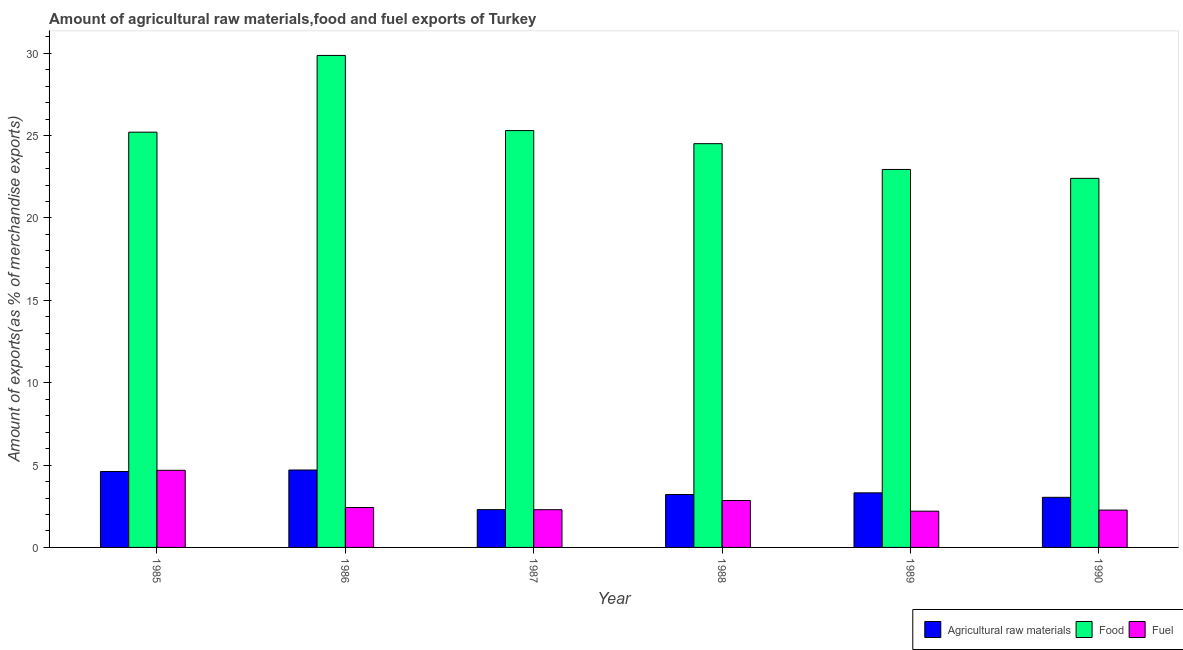How many different coloured bars are there?
Offer a terse response. 3. How many groups of bars are there?
Offer a very short reply. 6. How many bars are there on the 1st tick from the right?
Provide a succinct answer. 3. What is the label of the 3rd group of bars from the left?
Your answer should be very brief. 1987. What is the percentage of raw materials exports in 1986?
Make the answer very short. 4.7. Across all years, what is the maximum percentage of food exports?
Offer a very short reply. 29.87. Across all years, what is the minimum percentage of fuel exports?
Make the answer very short. 2.2. What is the total percentage of raw materials exports in the graph?
Your response must be concise. 21.17. What is the difference between the percentage of fuel exports in 1985 and that in 1989?
Offer a terse response. 2.48. What is the difference between the percentage of raw materials exports in 1985 and the percentage of food exports in 1988?
Make the answer very short. 1.4. What is the average percentage of raw materials exports per year?
Your answer should be compact. 3.53. In how many years, is the percentage of raw materials exports greater than 13 %?
Make the answer very short. 0. What is the ratio of the percentage of fuel exports in 1986 to that in 1990?
Provide a short and direct response. 1.07. Is the percentage of raw materials exports in 1985 less than that in 1988?
Your response must be concise. No. Is the difference between the percentage of food exports in 1985 and 1986 greater than the difference between the percentage of raw materials exports in 1985 and 1986?
Offer a very short reply. No. What is the difference between the highest and the second highest percentage of raw materials exports?
Ensure brevity in your answer.  0.09. What is the difference between the highest and the lowest percentage of fuel exports?
Keep it short and to the point. 2.48. What does the 2nd bar from the left in 1989 represents?
Your response must be concise. Food. What does the 3rd bar from the right in 1987 represents?
Provide a succinct answer. Agricultural raw materials. Are all the bars in the graph horizontal?
Ensure brevity in your answer.  No. How many years are there in the graph?
Offer a very short reply. 6. Are the values on the major ticks of Y-axis written in scientific E-notation?
Your answer should be very brief. No. Does the graph contain any zero values?
Your response must be concise. No. Where does the legend appear in the graph?
Offer a terse response. Bottom right. How many legend labels are there?
Provide a short and direct response. 3. How are the legend labels stacked?
Your answer should be compact. Horizontal. What is the title of the graph?
Give a very brief answer. Amount of agricultural raw materials,food and fuel exports of Turkey. Does "Solid fuel" appear as one of the legend labels in the graph?
Your response must be concise. No. What is the label or title of the X-axis?
Your answer should be very brief. Year. What is the label or title of the Y-axis?
Make the answer very short. Amount of exports(as % of merchandise exports). What is the Amount of exports(as % of merchandise exports) of Agricultural raw materials in 1985?
Your response must be concise. 4.61. What is the Amount of exports(as % of merchandise exports) in Food in 1985?
Your response must be concise. 25.21. What is the Amount of exports(as % of merchandise exports) of Fuel in 1985?
Keep it short and to the point. 4.68. What is the Amount of exports(as % of merchandise exports) in Agricultural raw materials in 1986?
Your answer should be very brief. 4.7. What is the Amount of exports(as % of merchandise exports) of Food in 1986?
Provide a succinct answer. 29.87. What is the Amount of exports(as % of merchandise exports) in Fuel in 1986?
Make the answer very short. 2.42. What is the Amount of exports(as % of merchandise exports) of Agricultural raw materials in 1987?
Give a very brief answer. 2.29. What is the Amount of exports(as % of merchandise exports) in Food in 1987?
Give a very brief answer. 25.3. What is the Amount of exports(as % of merchandise exports) of Fuel in 1987?
Give a very brief answer. 2.29. What is the Amount of exports(as % of merchandise exports) of Agricultural raw materials in 1988?
Provide a succinct answer. 3.21. What is the Amount of exports(as % of merchandise exports) in Food in 1988?
Give a very brief answer. 24.51. What is the Amount of exports(as % of merchandise exports) of Fuel in 1988?
Ensure brevity in your answer.  2.85. What is the Amount of exports(as % of merchandise exports) in Agricultural raw materials in 1989?
Provide a succinct answer. 3.31. What is the Amount of exports(as % of merchandise exports) in Food in 1989?
Your answer should be very brief. 22.94. What is the Amount of exports(as % of merchandise exports) in Fuel in 1989?
Give a very brief answer. 2.2. What is the Amount of exports(as % of merchandise exports) in Agricultural raw materials in 1990?
Your answer should be very brief. 3.04. What is the Amount of exports(as % of merchandise exports) in Food in 1990?
Offer a very short reply. 22.41. What is the Amount of exports(as % of merchandise exports) in Fuel in 1990?
Provide a short and direct response. 2.27. Across all years, what is the maximum Amount of exports(as % of merchandise exports) of Agricultural raw materials?
Your answer should be very brief. 4.7. Across all years, what is the maximum Amount of exports(as % of merchandise exports) of Food?
Provide a short and direct response. 29.87. Across all years, what is the maximum Amount of exports(as % of merchandise exports) of Fuel?
Keep it short and to the point. 4.68. Across all years, what is the minimum Amount of exports(as % of merchandise exports) in Agricultural raw materials?
Offer a very short reply. 2.29. Across all years, what is the minimum Amount of exports(as % of merchandise exports) of Food?
Your answer should be very brief. 22.41. Across all years, what is the minimum Amount of exports(as % of merchandise exports) in Fuel?
Give a very brief answer. 2.2. What is the total Amount of exports(as % of merchandise exports) in Agricultural raw materials in the graph?
Ensure brevity in your answer.  21.17. What is the total Amount of exports(as % of merchandise exports) of Food in the graph?
Provide a succinct answer. 150.24. What is the total Amount of exports(as % of merchandise exports) of Fuel in the graph?
Ensure brevity in your answer.  16.71. What is the difference between the Amount of exports(as % of merchandise exports) in Agricultural raw materials in 1985 and that in 1986?
Provide a short and direct response. -0.09. What is the difference between the Amount of exports(as % of merchandise exports) of Food in 1985 and that in 1986?
Offer a terse response. -4.66. What is the difference between the Amount of exports(as % of merchandise exports) in Fuel in 1985 and that in 1986?
Your answer should be very brief. 2.26. What is the difference between the Amount of exports(as % of merchandise exports) of Agricultural raw materials in 1985 and that in 1987?
Provide a short and direct response. 2.32. What is the difference between the Amount of exports(as % of merchandise exports) in Food in 1985 and that in 1987?
Offer a very short reply. -0.1. What is the difference between the Amount of exports(as % of merchandise exports) of Fuel in 1985 and that in 1987?
Your response must be concise. 2.39. What is the difference between the Amount of exports(as % of merchandise exports) of Agricultural raw materials in 1985 and that in 1988?
Ensure brevity in your answer.  1.4. What is the difference between the Amount of exports(as % of merchandise exports) of Food in 1985 and that in 1988?
Ensure brevity in your answer.  0.7. What is the difference between the Amount of exports(as % of merchandise exports) in Fuel in 1985 and that in 1988?
Offer a terse response. 1.83. What is the difference between the Amount of exports(as % of merchandise exports) in Agricultural raw materials in 1985 and that in 1989?
Ensure brevity in your answer.  1.3. What is the difference between the Amount of exports(as % of merchandise exports) in Food in 1985 and that in 1989?
Offer a very short reply. 2.26. What is the difference between the Amount of exports(as % of merchandise exports) of Fuel in 1985 and that in 1989?
Give a very brief answer. 2.48. What is the difference between the Amount of exports(as % of merchandise exports) of Agricultural raw materials in 1985 and that in 1990?
Provide a succinct answer. 1.57. What is the difference between the Amount of exports(as % of merchandise exports) of Food in 1985 and that in 1990?
Your answer should be very brief. 2.8. What is the difference between the Amount of exports(as % of merchandise exports) in Fuel in 1985 and that in 1990?
Your answer should be compact. 2.41. What is the difference between the Amount of exports(as % of merchandise exports) in Agricultural raw materials in 1986 and that in 1987?
Provide a succinct answer. 2.41. What is the difference between the Amount of exports(as % of merchandise exports) of Food in 1986 and that in 1987?
Your answer should be compact. 4.56. What is the difference between the Amount of exports(as % of merchandise exports) of Fuel in 1986 and that in 1987?
Provide a succinct answer. 0.13. What is the difference between the Amount of exports(as % of merchandise exports) in Agricultural raw materials in 1986 and that in 1988?
Offer a terse response. 1.49. What is the difference between the Amount of exports(as % of merchandise exports) in Food in 1986 and that in 1988?
Provide a succinct answer. 5.36. What is the difference between the Amount of exports(as % of merchandise exports) of Fuel in 1986 and that in 1988?
Provide a succinct answer. -0.43. What is the difference between the Amount of exports(as % of merchandise exports) in Agricultural raw materials in 1986 and that in 1989?
Your response must be concise. 1.39. What is the difference between the Amount of exports(as % of merchandise exports) in Food in 1986 and that in 1989?
Offer a very short reply. 6.92. What is the difference between the Amount of exports(as % of merchandise exports) of Fuel in 1986 and that in 1989?
Provide a succinct answer. 0.22. What is the difference between the Amount of exports(as % of merchandise exports) in Agricultural raw materials in 1986 and that in 1990?
Your answer should be compact. 1.66. What is the difference between the Amount of exports(as % of merchandise exports) in Food in 1986 and that in 1990?
Give a very brief answer. 7.46. What is the difference between the Amount of exports(as % of merchandise exports) of Fuel in 1986 and that in 1990?
Provide a succinct answer. 0.16. What is the difference between the Amount of exports(as % of merchandise exports) of Agricultural raw materials in 1987 and that in 1988?
Ensure brevity in your answer.  -0.92. What is the difference between the Amount of exports(as % of merchandise exports) of Food in 1987 and that in 1988?
Keep it short and to the point. 0.79. What is the difference between the Amount of exports(as % of merchandise exports) in Fuel in 1987 and that in 1988?
Give a very brief answer. -0.56. What is the difference between the Amount of exports(as % of merchandise exports) in Agricultural raw materials in 1987 and that in 1989?
Your response must be concise. -1.02. What is the difference between the Amount of exports(as % of merchandise exports) of Food in 1987 and that in 1989?
Provide a short and direct response. 2.36. What is the difference between the Amount of exports(as % of merchandise exports) of Fuel in 1987 and that in 1989?
Keep it short and to the point. 0.09. What is the difference between the Amount of exports(as % of merchandise exports) of Agricultural raw materials in 1987 and that in 1990?
Offer a terse response. -0.75. What is the difference between the Amount of exports(as % of merchandise exports) in Food in 1987 and that in 1990?
Provide a short and direct response. 2.9. What is the difference between the Amount of exports(as % of merchandise exports) in Fuel in 1987 and that in 1990?
Give a very brief answer. 0.02. What is the difference between the Amount of exports(as % of merchandise exports) of Agricultural raw materials in 1988 and that in 1989?
Your answer should be compact. -0.1. What is the difference between the Amount of exports(as % of merchandise exports) of Food in 1988 and that in 1989?
Offer a very short reply. 1.56. What is the difference between the Amount of exports(as % of merchandise exports) of Fuel in 1988 and that in 1989?
Provide a short and direct response. 0.65. What is the difference between the Amount of exports(as % of merchandise exports) of Agricultural raw materials in 1988 and that in 1990?
Keep it short and to the point. 0.17. What is the difference between the Amount of exports(as % of merchandise exports) of Food in 1988 and that in 1990?
Give a very brief answer. 2.1. What is the difference between the Amount of exports(as % of merchandise exports) in Fuel in 1988 and that in 1990?
Make the answer very short. 0.58. What is the difference between the Amount of exports(as % of merchandise exports) in Agricultural raw materials in 1989 and that in 1990?
Your response must be concise. 0.27. What is the difference between the Amount of exports(as % of merchandise exports) of Food in 1989 and that in 1990?
Make the answer very short. 0.54. What is the difference between the Amount of exports(as % of merchandise exports) of Fuel in 1989 and that in 1990?
Ensure brevity in your answer.  -0.07. What is the difference between the Amount of exports(as % of merchandise exports) of Agricultural raw materials in 1985 and the Amount of exports(as % of merchandise exports) of Food in 1986?
Keep it short and to the point. -25.26. What is the difference between the Amount of exports(as % of merchandise exports) of Agricultural raw materials in 1985 and the Amount of exports(as % of merchandise exports) of Fuel in 1986?
Offer a terse response. 2.19. What is the difference between the Amount of exports(as % of merchandise exports) of Food in 1985 and the Amount of exports(as % of merchandise exports) of Fuel in 1986?
Ensure brevity in your answer.  22.79. What is the difference between the Amount of exports(as % of merchandise exports) of Agricultural raw materials in 1985 and the Amount of exports(as % of merchandise exports) of Food in 1987?
Ensure brevity in your answer.  -20.69. What is the difference between the Amount of exports(as % of merchandise exports) of Agricultural raw materials in 1985 and the Amount of exports(as % of merchandise exports) of Fuel in 1987?
Make the answer very short. 2.32. What is the difference between the Amount of exports(as % of merchandise exports) of Food in 1985 and the Amount of exports(as % of merchandise exports) of Fuel in 1987?
Provide a succinct answer. 22.92. What is the difference between the Amount of exports(as % of merchandise exports) in Agricultural raw materials in 1985 and the Amount of exports(as % of merchandise exports) in Food in 1988?
Ensure brevity in your answer.  -19.9. What is the difference between the Amount of exports(as % of merchandise exports) of Agricultural raw materials in 1985 and the Amount of exports(as % of merchandise exports) of Fuel in 1988?
Keep it short and to the point. 1.76. What is the difference between the Amount of exports(as % of merchandise exports) in Food in 1985 and the Amount of exports(as % of merchandise exports) in Fuel in 1988?
Offer a terse response. 22.36. What is the difference between the Amount of exports(as % of merchandise exports) in Agricultural raw materials in 1985 and the Amount of exports(as % of merchandise exports) in Food in 1989?
Offer a terse response. -18.34. What is the difference between the Amount of exports(as % of merchandise exports) in Agricultural raw materials in 1985 and the Amount of exports(as % of merchandise exports) in Fuel in 1989?
Ensure brevity in your answer.  2.41. What is the difference between the Amount of exports(as % of merchandise exports) of Food in 1985 and the Amount of exports(as % of merchandise exports) of Fuel in 1989?
Your response must be concise. 23.01. What is the difference between the Amount of exports(as % of merchandise exports) of Agricultural raw materials in 1985 and the Amount of exports(as % of merchandise exports) of Food in 1990?
Offer a very short reply. -17.8. What is the difference between the Amount of exports(as % of merchandise exports) in Agricultural raw materials in 1985 and the Amount of exports(as % of merchandise exports) in Fuel in 1990?
Your response must be concise. 2.34. What is the difference between the Amount of exports(as % of merchandise exports) of Food in 1985 and the Amount of exports(as % of merchandise exports) of Fuel in 1990?
Give a very brief answer. 22.94. What is the difference between the Amount of exports(as % of merchandise exports) of Agricultural raw materials in 1986 and the Amount of exports(as % of merchandise exports) of Food in 1987?
Make the answer very short. -20.6. What is the difference between the Amount of exports(as % of merchandise exports) in Agricultural raw materials in 1986 and the Amount of exports(as % of merchandise exports) in Fuel in 1987?
Give a very brief answer. 2.41. What is the difference between the Amount of exports(as % of merchandise exports) in Food in 1986 and the Amount of exports(as % of merchandise exports) in Fuel in 1987?
Offer a very short reply. 27.58. What is the difference between the Amount of exports(as % of merchandise exports) in Agricultural raw materials in 1986 and the Amount of exports(as % of merchandise exports) in Food in 1988?
Keep it short and to the point. -19.81. What is the difference between the Amount of exports(as % of merchandise exports) of Agricultural raw materials in 1986 and the Amount of exports(as % of merchandise exports) of Fuel in 1988?
Your response must be concise. 1.85. What is the difference between the Amount of exports(as % of merchandise exports) of Food in 1986 and the Amount of exports(as % of merchandise exports) of Fuel in 1988?
Give a very brief answer. 27.02. What is the difference between the Amount of exports(as % of merchandise exports) in Agricultural raw materials in 1986 and the Amount of exports(as % of merchandise exports) in Food in 1989?
Provide a succinct answer. -18.25. What is the difference between the Amount of exports(as % of merchandise exports) of Agricultural raw materials in 1986 and the Amount of exports(as % of merchandise exports) of Fuel in 1989?
Your response must be concise. 2.5. What is the difference between the Amount of exports(as % of merchandise exports) of Food in 1986 and the Amount of exports(as % of merchandise exports) of Fuel in 1989?
Ensure brevity in your answer.  27.67. What is the difference between the Amount of exports(as % of merchandise exports) of Agricultural raw materials in 1986 and the Amount of exports(as % of merchandise exports) of Food in 1990?
Offer a very short reply. -17.71. What is the difference between the Amount of exports(as % of merchandise exports) of Agricultural raw materials in 1986 and the Amount of exports(as % of merchandise exports) of Fuel in 1990?
Your response must be concise. 2.43. What is the difference between the Amount of exports(as % of merchandise exports) in Food in 1986 and the Amount of exports(as % of merchandise exports) in Fuel in 1990?
Keep it short and to the point. 27.6. What is the difference between the Amount of exports(as % of merchandise exports) of Agricultural raw materials in 1987 and the Amount of exports(as % of merchandise exports) of Food in 1988?
Your answer should be compact. -22.22. What is the difference between the Amount of exports(as % of merchandise exports) of Agricultural raw materials in 1987 and the Amount of exports(as % of merchandise exports) of Fuel in 1988?
Your answer should be compact. -0.55. What is the difference between the Amount of exports(as % of merchandise exports) in Food in 1987 and the Amount of exports(as % of merchandise exports) in Fuel in 1988?
Offer a very short reply. 22.46. What is the difference between the Amount of exports(as % of merchandise exports) of Agricultural raw materials in 1987 and the Amount of exports(as % of merchandise exports) of Food in 1989?
Provide a short and direct response. -20.65. What is the difference between the Amount of exports(as % of merchandise exports) in Agricultural raw materials in 1987 and the Amount of exports(as % of merchandise exports) in Fuel in 1989?
Your response must be concise. 0.09. What is the difference between the Amount of exports(as % of merchandise exports) of Food in 1987 and the Amount of exports(as % of merchandise exports) of Fuel in 1989?
Give a very brief answer. 23.1. What is the difference between the Amount of exports(as % of merchandise exports) of Agricultural raw materials in 1987 and the Amount of exports(as % of merchandise exports) of Food in 1990?
Offer a very short reply. -20.11. What is the difference between the Amount of exports(as % of merchandise exports) in Agricultural raw materials in 1987 and the Amount of exports(as % of merchandise exports) in Fuel in 1990?
Your answer should be very brief. 0.03. What is the difference between the Amount of exports(as % of merchandise exports) of Food in 1987 and the Amount of exports(as % of merchandise exports) of Fuel in 1990?
Keep it short and to the point. 23.04. What is the difference between the Amount of exports(as % of merchandise exports) of Agricultural raw materials in 1988 and the Amount of exports(as % of merchandise exports) of Food in 1989?
Offer a terse response. -19.73. What is the difference between the Amount of exports(as % of merchandise exports) of Agricultural raw materials in 1988 and the Amount of exports(as % of merchandise exports) of Fuel in 1989?
Your answer should be compact. 1.01. What is the difference between the Amount of exports(as % of merchandise exports) of Food in 1988 and the Amount of exports(as % of merchandise exports) of Fuel in 1989?
Offer a very short reply. 22.31. What is the difference between the Amount of exports(as % of merchandise exports) of Agricultural raw materials in 1988 and the Amount of exports(as % of merchandise exports) of Food in 1990?
Offer a very short reply. -19.19. What is the difference between the Amount of exports(as % of merchandise exports) of Agricultural raw materials in 1988 and the Amount of exports(as % of merchandise exports) of Fuel in 1990?
Provide a succinct answer. 0.95. What is the difference between the Amount of exports(as % of merchandise exports) of Food in 1988 and the Amount of exports(as % of merchandise exports) of Fuel in 1990?
Ensure brevity in your answer.  22.24. What is the difference between the Amount of exports(as % of merchandise exports) in Agricultural raw materials in 1989 and the Amount of exports(as % of merchandise exports) in Food in 1990?
Offer a terse response. -19.09. What is the difference between the Amount of exports(as % of merchandise exports) in Agricultural raw materials in 1989 and the Amount of exports(as % of merchandise exports) in Fuel in 1990?
Your answer should be compact. 1.05. What is the difference between the Amount of exports(as % of merchandise exports) in Food in 1989 and the Amount of exports(as % of merchandise exports) in Fuel in 1990?
Make the answer very short. 20.68. What is the average Amount of exports(as % of merchandise exports) in Agricultural raw materials per year?
Offer a very short reply. 3.53. What is the average Amount of exports(as % of merchandise exports) in Food per year?
Keep it short and to the point. 25.04. What is the average Amount of exports(as % of merchandise exports) in Fuel per year?
Provide a short and direct response. 2.79. In the year 1985, what is the difference between the Amount of exports(as % of merchandise exports) in Agricultural raw materials and Amount of exports(as % of merchandise exports) in Food?
Make the answer very short. -20.6. In the year 1985, what is the difference between the Amount of exports(as % of merchandise exports) in Agricultural raw materials and Amount of exports(as % of merchandise exports) in Fuel?
Keep it short and to the point. -0.07. In the year 1985, what is the difference between the Amount of exports(as % of merchandise exports) of Food and Amount of exports(as % of merchandise exports) of Fuel?
Keep it short and to the point. 20.53. In the year 1986, what is the difference between the Amount of exports(as % of merchandise exports) of Agricultural raw materials and Amount of exports(as % of merchandise exports) of Food?
Your answer should be compact. -25.17. In the year 1986, what is the difference between the Amount of exports(as % of merchandise exports) in Agricultural raw materials and Amount of exports(as % of merchandise exports) in Fuel?
Your response must be concise. 2.28. In the year 1986, what is the difference between the Amount of exports(as % of merchandise exports) of Food and Amount of exports(as % of merchandise exports) of Fuel?
Make the answer very short. 27.44. In the year 1987, what is the difference between the Amount of exports(as % of merchandise exports) in Agricultural raw materials and Amount of exports(as % of merchandise exports) in Food?
Offer a very short reply. -23.01. In the year 1987, what is the difference between the Amount of exports(as % of merchandise exports) in Agricultural raw materials and Amount of exports(as % of merchandise exports) in Fuel?
Your answer should be compact. 0. In the year 1987, what is the difference between the Amount of exports(as % of merchandise exports) of Food and Amount of exports(as % of merchandise exports) of Fuel?
Your answer should be very brief. 23.01. In the year 1988, what is the difference between the Amount of exports(as % of merchandise exports) of Agricultural raw materials and Amount of exports(as % of merchandise exports) of Food?
Offer a terse response. -21.3. In the year 1988, what is the difference between the Amount of exports(as % of merchandise exports) in Agricultural raw materials and Amount of exports(as % of merchandise exports) in Fuel?
Make the answer very short. 0.36. In the year 1988, what is the difference between the Amount of exports(as % of merchandise exports) in Food and Amount of exports(as % of merchandise exports) in Fuel?
Keep it short and to the point. 21.66. In the year 1989, what is the difference between the Amount of exports(as % of merchandise exports) of Agricultural raw materials and Amount of exports(as % of merchandise exports) of Food?
Your answer should be very brief. -19.63. In the year 1989, what is the difference between the Amount of exports(as % of merchandise exports) of Agricultural raw materials and Amount of exports(as % of merchandise exports) of Fuel?
Make the answer very short. 1.11. In the year 1989, what is the difference between the Amount of exports(as % of merchandise exports) of Food and Amount of exports(as % of merchandise exports) of Fuel?
Provide a short and direct response. 20.74. In the year 1990, what is the difference between the Amount of exports(as % of merchandise exports) of Agricultural raw materials and Amount of exports(as % of merchandise exports) of Food?
Offer a very short reply. -19.36. In the year 1990, what is the difference between the Amount of exports(as % of merchandise exports) of Agricultural raw materials and Amount of exports(as % of merchandise exports) of Fuel?
Your response must be concise. 0.78. In the year 1990, what is the difference between the Amount of exports(as % of merchandise exports) of Food and Amount of exports(as % of merchandise exports) of Fuel?
Offer a very short reply. 20.14. What is the ratio of the Amount of exports(as % of merchandise exports) of Agricultural raw materials in 1985 to that in 1986?
Your answer should be compact. 0.98. What is the ratio of the Amount of exports(as % of merchandise exports) of Food in 1985 to that in 1986?
Your response must be concise. 0.84. What is the ratio of the Amount of exports(as % of merchandise exports) of Fuel in 1985 to that in 1986?
Provide a succinct answer. 1.93. What is the ratio of the Amount of exports(as % of merchandise exports) of Agricultural raw materials in 1985 to that in 1987?
Ensure brevity in your answer.  2.01. What is the ratio of the Amount of exports(as % of merchandise exports) of Food in 1985 to that in 1987?
Give a very brief answer. 1. What is the ratio of the Amount of exports(as % of merchandise exports) in Fuel in 1985 to that in 1987?
Your response must be concise. 2.04. What is the ratio of the Amount of exports(as % of merchandise exports) in Agricultural raw materials in 1985 to that in 1988?
Ensure brevity in your answer.  1.43. What is the ratio of the Amount of exports(as % of merchandise exports) of Food in 1985 to that in 1988?
Your response must be concise. 1.03. What is the ratio of the Amount of exports(as % of merchandise exports) of Fuel in 1985 to that in 1988?
Your answer should be compact. 1.64. What is the ratio of the Amount of exports(as % of merchandise exports) in Agricultural raw materials in 1985 to that in 1989?
Offer a very short reply. 1.39. What is the ratio of the Amount of exports(as % of merchandise exports) of Food in 1985 to that in 1989?
Provide a succinct answer. 1.1. What is the ratio of the Amount of exports(as % of merchandise exports) in Fuel in 1985 to that in 1989?
Offer a very short reply. 2.13. What is the ratio of the Amount of exports(as % of merchandise exports) in Agricultural raw materials in 1985 to that in 1990?
Offer a terse response. 1.52. What is the ratio of the Amount of exports(as % of merchandise exports) of Food in 1985 to that in 1990?
Ensure brevity in your answer.  1.13. What is the ratio of the Amount of exports(as % of merchandise exports) of Fuel in 1985 to that in 1990?
Your answer should be very brief. 2.07. What is the ratio of the Amount of exports(as % of merchandise exports) of Agricultural raw materials in 1986 to that in 1987?
Provide a succinct answer. 2.05. What is the ratio of the Amount of exports(as % of merchandise exports) in Food in 1986 to that in 1987?
Ensure brevity in your answer.  1.18. What is the ratio of the Amount of exports(as % of merchandise exports) of Fuel in 1986 to that in 1987?
Your answer should be very brief. 1.06. What is the ratio of the Amount of exports(as % of merchandise exports) of Agricultural raw materials in 1986 to that in 1988?
Ensure brevity in your answer.  1.46. What is the ratio of the Amount of exports(as % of merchandise exports) of Food in 1986 to that in 1988?
Your answer should be very brief. 1.22. What is the ratio of the Amount of exports(as % of merchandise exports) of Fuel in 1986 to that in 1988?
Your answer should be compact. 0.85. What is the ratio of the Amount of exports(as % of merchandise exports) in Agricultural raw materials in 1986 to that in 1989?
Offer a terse response. 1.42. What is the ratio of the Amount of exports(as % of merchandise exports) of Food in 1986 to that in 1989?
Your response must be concise. 1.3. What is the ratio of the Amount of exports(as % of merchandise exports) in Fuel in 1986 to that in 1989?
Your answer should be compact. 1.1. What is the ratio of the Amount of exports(as % of merchandise exports) of Agricultural raw materials in 1986 to that in 1990?
Provide a short and direct response. 1.54. What is the ratio of the Amount of exports(as % of merchandise exports) of Food in 1986 to that in 1990?
Give a very brief answer. 1.33. What is the ratio of the Amount of exports(as % of merchandise exports) of Fuel in 1986 to that in 1990?
Give a very brief answer. 1.07. What is the ratio of the Amount of exports(as % of merchandise exports) in Agricultural raw materials in 1987 to that in 1988?
Offer a terse response. 0.71. What is the ratio of the Amount of exports(as % of merchandise exports) of Food in 1987 to that in 1988?
Give a very brief answer. 1.03. What is the ratio of the Amount of exports(as % of merchandise exports) of Fuel in 1987 to that in 1988?
Keep it short and to the point. 0.8. What is the ratio of the Amount of exports(as % of merchandise exports) of Agricultural raw materials in 1987 to that in 1989?
Your answer should be very brief. 0.69. What is the ratio of the Amount of exports(as % of merchandise exports) of Food in 1987 to that in 1989?
Your answer should be very brief. 1.1. What is the ratio of the Amount of exports(as % of merchandise exports) of Fuel in 1987 to that in 1989?
Ensure brevity in your answer.  1.04. What is the ratio of the Amount of exports(as % of merchandise exports) of Agricultural raw materials in 1987 to that in 1990?
Your answer should be very brief. 0.75. What is the ratio of the Amount of exports(as % of merchandise exports) of Food in 1987 to that in 1990?
Your response must be concise. 1.13. What is the ratio of the Amount of exports(as % of merchandise exports) of Fuel in 1987 to that in 1990?
Your answer should be very brief. 1.01. What is the ratio of the Amount of exports(as % of merchandise exports) in Agricultural raw materials in 1988 to that in 1989?
Your response must be concise. 0.97. What is the ratio of the Amount of exports(as % of merchandise exports) in Food in 1988 to that in 1989?
Your response must be concise. 1.07. What is the ratio of the Amount of exports(as % of merchandise exports) in Fuel in 1988 to that in 1989?
Make the answer very short. 1.29. What is the ratio of the Amount of exports(as % of merchandise exports) of Agricultural raw materials in 1988 to that in 1990?
Provide a short and direct response. 1.06. What is the ratio of the Amount of exports(as % of merchandise exports) of Food in 1988 to that in 1990?
Your response must be concise. 1.09. What is the ratio of the Amount of exports(as % of merchandise exports) in Fuel in 1988 to that in 1990?
Give a very brief answer. 1.26. What is the ratio of the Amount of exports(as % of merchandise exports) in Agricultural raw materials in 1989 to that in 1990?
Ensure brevity in your answer.  1.09. What is the ratio of the Amount of exports(as % of merchandise exports) of Food in 1989 to that in 1990?
Offer a very short reply. 1.02. What is the ratio of the Amount of exports(as % of merchandise exports) in Fuel in 1989 to that in 1990?
Keep it short and to the point. 0.97. What is the difference between the highest and the second highest Amount of exports(as % of merchandise exports) in Agricultural raw materials?
Provide a short and direct response. 0.09. What is the difference between the highest and the second highest Amount of exports(as % of merchandise exports) in Food?
Keep it short and to the point. 4.56. What is the difference between the highest and the second highest Amount of exports(as % of merchandise exports) of Fuel?
Your answer should be very brief. 1.83. What is the difference between the highest and the lowest Amount of exports(as % of merchandise exports) of Agricultural raw materials?
Offer a very short reply. 2.41. What is the difference between the highest and the lowest Amount of exports(as % of merchandise exports) in Food?
Give a very brief answer. 7.46. What is the difference between the highest and the lowest Amount of exports(as % of merchandise exports) in Fuel?
Ensure brevity in your answer.  2.48. 